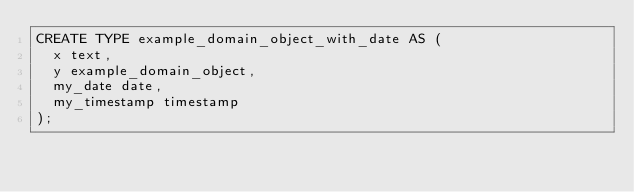<code> <loc_0><loc_0><loc_500><loc_500><_SQL_>CREATE TYPE example_domain_object_with_date AS (
  x text,
  y example_domain_object,
  my_date date,
  my_timestamp timestamp
);
</code> 